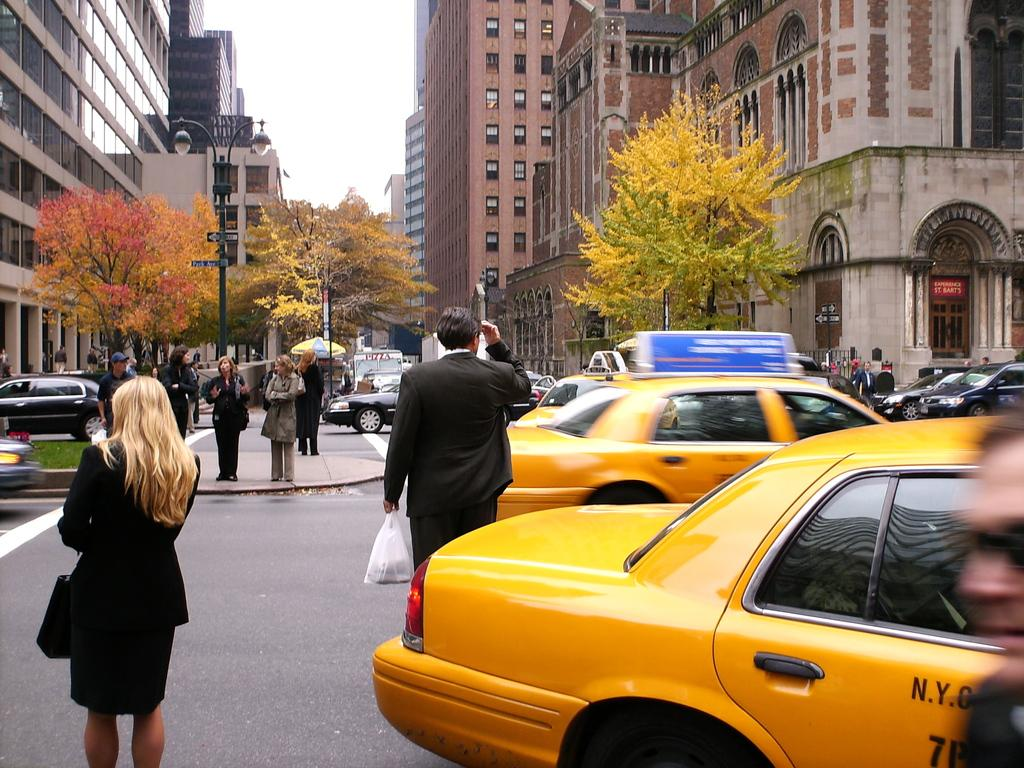<image>
Describe the image concisely. a cab that has NY on the front with a lady next to it 